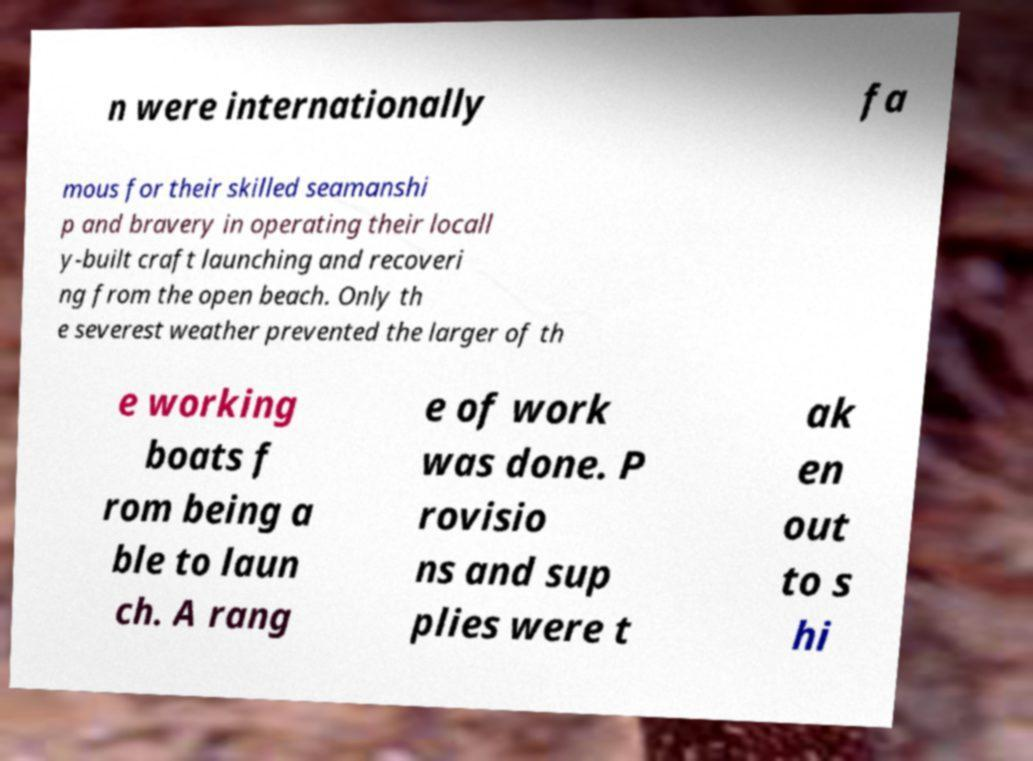Could you assist in decoding the text presented in this image and type it out clearly? n were internationally fa mous for their skilled seamanshi p and bravery in operating their locall y-built craft launching and recoveri ng from the open beach. Only th e severest weather prevented the larger of th e working boats f rom being a ble to laun ch. A rang e of work was done. P rovisio ns and sup plies were t ak en out to s hi 